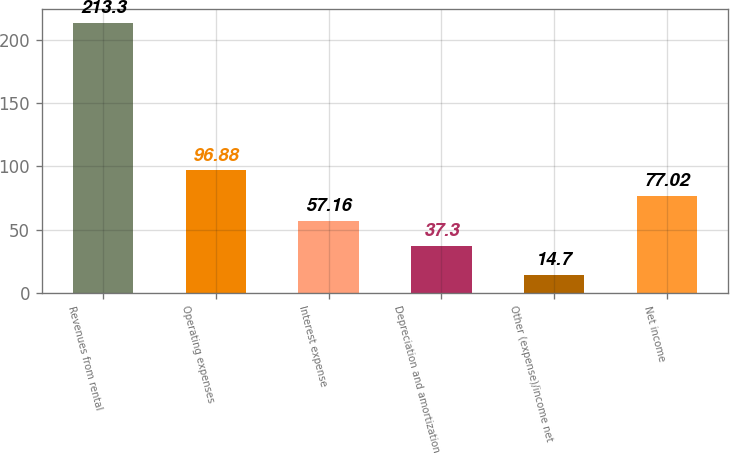Convert chart. <chart><loc_0><loc_0><loc_500><loc_500><bar_chart><fcel>Revenues from rental<fcel>Operating expenses<fcel>Interest expense<fcel>Depreciation and amortization<fcel>Other (expense)/income net<fcel>Net income<nl><fcel>213.3<fcel>96.88<fcel>57.16<fcel>37.3<fcel>14.7<fcel>77.02<nl></chart> 